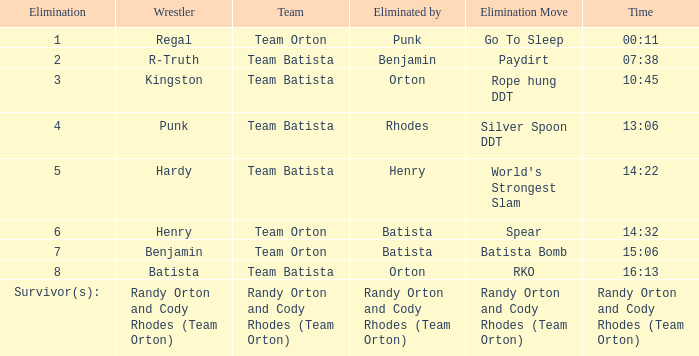What is the Elimination move listed against Regal? Go To Sleep. 